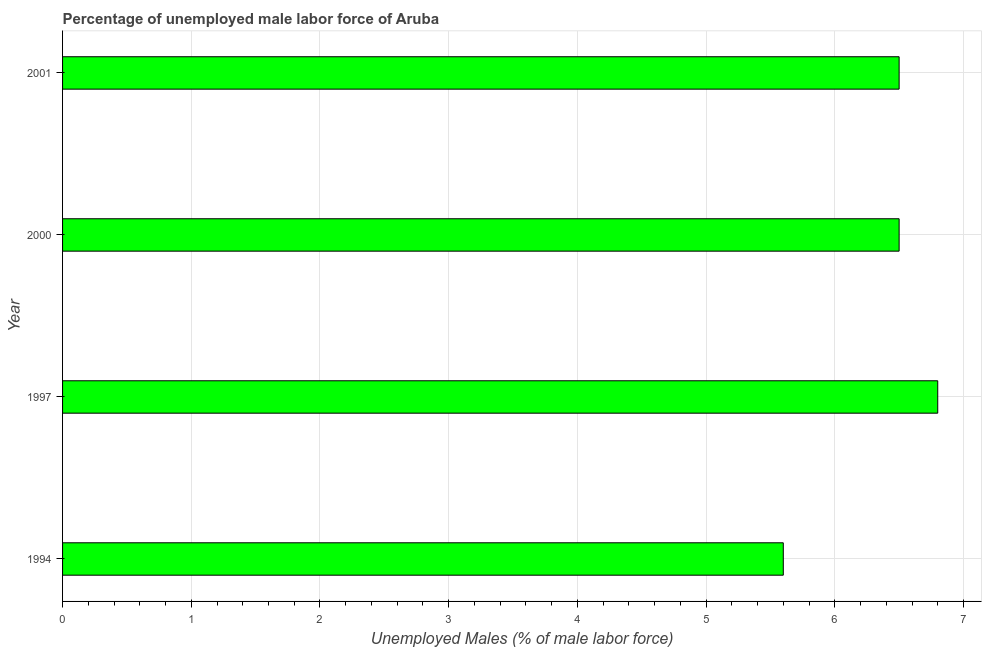Does the graph contain grids?
Give a very brief answer. Yes. What is the title of the graph?
Your answer should be very brief. Percentage of unemployed male labor force of Aruba. What is the label or title of the X-axis?
Offer a terse response. Unemployed Males (% of male labor force). What is the label or title of the Y-axis?
Your response must be concise. Year. What is the total unemployed male labour force in 1997?
Provide a short and direct response. 6.8. Across all years, what is the maximum total unemployed male labour force?
Your answer should be compact. 6.8. Across all years, what is the minimum total unemployed male labour force?
Provide a short and direct response. 5.6. In which year was the total unemployed male labour force maximum?
Offer a terse response. 1997. What is the sum of the total unemployed male labour force?
Keep it short and to the point. 25.4. What is the average total unemployed male labour force per year?
Ensure brevity in your answer.  6.35. What is the median total unemployed male labour force?
Offer a very short reply. 6.5. In how many years, is the total unemployed male labour force greater than 0.4 %?
Make the answer very short. 4. Do a majority of the years between 2001 and 1994 (inclusive) have total unemployed male labour force greater than 2.4 %?
Make the answer very short. Yes. What is the ratio of the total unemployed male labour force in 1994 to that in 1997?
Your response must be concise. 0.82. Is the difference between the total unemployed male labour force in 2000 and 2001 greater than the difference between any two years?
Offer a very short reply. No. How many years are there in the graph?
Offer a very short reply. 4. Are the values on the major ticks of X-axis written in scientific E-notation?
Make the answer very short. No. What is the Unemployed Males (% of male labor force) in 1994?
Make the answer very short. 5.6. What is the Unemployed Males (% of male labor force) of 1997?
Offer a very short reply. 6.8. What is the difference between the Unemployed Males (% of male labor force) in 1997 and 2000?
Offer a very short reply. 0.3. What is the difference between the Unemployed Males (% of male labor force) in 1997 and 2001?
Offer a terse response. 0.3. What is the difference between the Unemployed Males (% of male labor force) in 2000 and 2001?
Provide a succinct answer. 0. What is the ratio of the Unemployed Males (% of male labor force) in 1994 to that in 1997?
Ensure brevity in your answer.  0.82. What is the ratio of the Unemployed Males (% of male labor force) in 1994 to that in 2000?
Your response must be concise. 0.86. What is the ratio of the Unemployed Males (% of male labor force) in 1994 to that in 2001?
Provide a short and direct response. 0.86. What is the ratio of the Unemployed Males (% of male labor force) in 1997 to that in 2000?
Your response must be concise. 1.05. What is the ratio of the Unemployed Males (% of male labor force) in 1997 to that in 2001?
Your response must be concise. 1.05. 